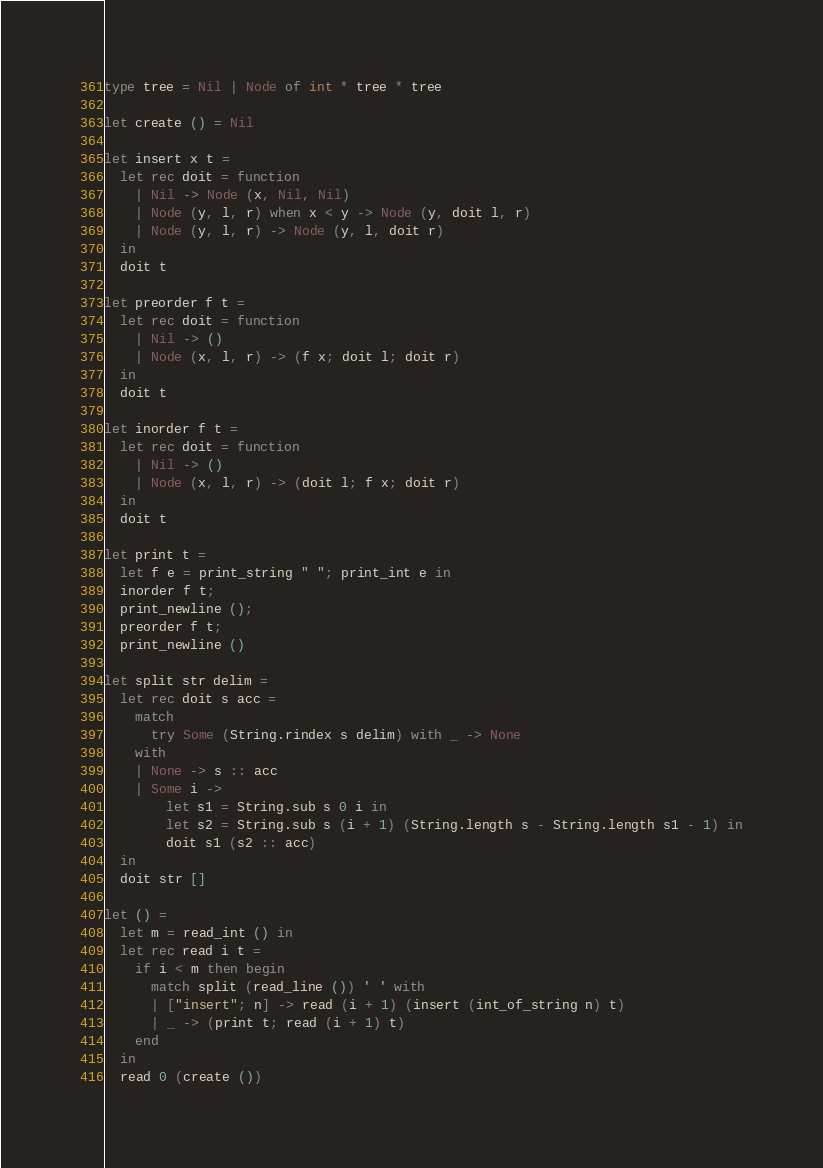<code> <loc_0><loc_0><loc_500><loc_500><_OCaml_>type tree = Nil | Node of int * tree * tree

let create () = Nil

let insert x t =
  let rec doit = function
    | Nil -> Node (x, Nil, Nil)
    | Node (y, l, r) when x < y -> Node (y, doit l, r)
    | Node (y, l, r) -> Node (y, l, doit r)
  in
  doit t

let preorder f t =
  let rec doit = function
    | Nil -> ()
    | Node (x, l, r) -> (f x; doit l; doit r)
  in
  doit t

let inorder f t =
  let rec doit = function
    | Nil -> ()
    | Node (x, l, r) -> (doit l; f x; doit r)
  in
  doit t

let print t =
  let f e = print_string " "; print_int e in
  inorder f t;
  print_newline ();
  preorder f t;
  print_newline ()

let split str delim =
  let rec doit s acc =
    match
      try Some (String.rindex s delim) with _ -> None
    with
    | None -> s :: acc
    | Some i ->
        let s1 = String.sub s 0 i in
        let s2 = String.sub s (i + 1) (String.length s - String.length s1 - 1) in
        doit s1 (s2 :: acc)
  in
  doit str []

let () =
  let m = read_int () in
  let rec read i t =
    if i < m then begin
      match split (read_line ()) ' ' with
      | ["insert"; n] -> read (i + 1) (insert (int_of_string n) t)
      | _ -> (print t; read (i + 1) t)
    end
  in
  read 0 (create ())</code> 